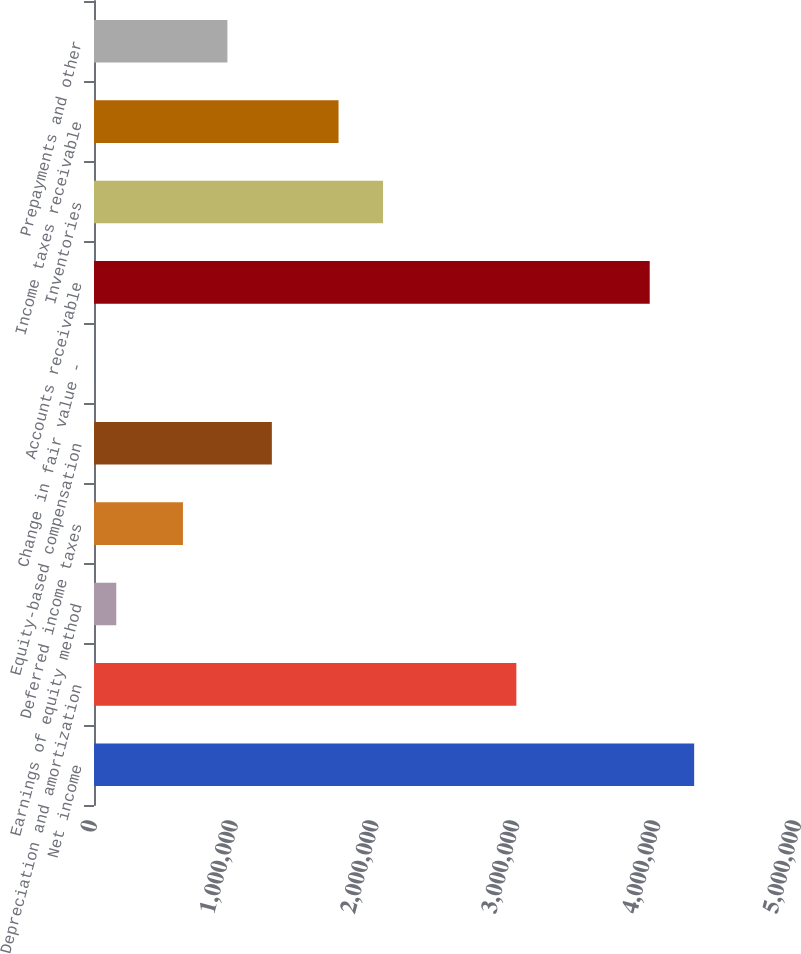Convert chart to OTSL. <chart><loc_0><loc_0><loc_500><loc_500><bar_chart><fcel>Net income<fcel>Depreciation and amortization<fcel>Earnings of equity method<fcel>Deferred income taxes<fcel>Equity-based compensation<fcel>Change in fair value -<fcel>Accounts receivable<fcel>Inventories<fcel>Income taxes receivable<fcel>Prepayments and other<nl><fcel>4.26252e+06<fcel>2.99964e+06<fcel>158166<fcel>631745<fcel>1.26318e+06<fcel>306<fcel>3.9468e+06<fcel>2.05248e+06<fcel>1.73676e+06<fcel>947465<nl></chart> 